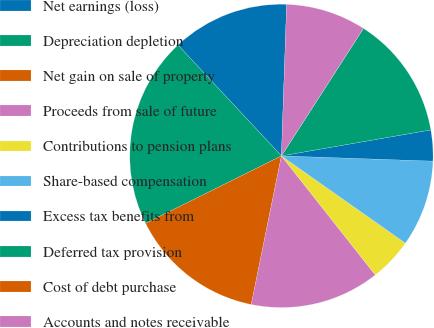Convert chart. <chart><loc_0><loc_0><loc_500><loc_500><pie_chart><fcel>Net earnings (loss)<fcel>Depreciation depletion<fcel>Net gain on sale of property<fcel>Proceeds from sale of future<fcel>Contributions to pension plans<fcel>Share-based compensation<fcel>Excess tax benefits from<fcel>Deferred tax provision<fcel>Cost of debt purchase<fcel>Accounts and notes receivable<nl><fcel>12.5%<fcel>20.39%<fcel>14.47%<fcel>13.82%<fcel>4.61%<fcel>9.21%<fcel>3.29%<fcel>13.16%<fcel>0.0%<fcel>8.55%<nl></chart> 